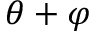Convert formula to latex. <formula><loc_0><loc_0><loc_500><loc_500>\theta + \varphi</formula> 